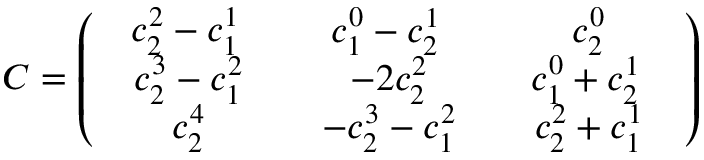Convert formula to latex. <formula><loc_0><loc_0><loc_500><loc_500>C = \left ( \begin{array} { c c c } { { \begin{array} { c } { { c _ { 2 } ^ { 2 } - c _ { 1 } ^ { 1 } } } \end{array} \, } } & { { \begin{array} { c } { { c _ { 1 } ^ { 0 } - c _ { 2 } ^ { 1 } } } \end{array} \, } } & { { \begin{array} { c } { { c _ { 2 } ^ { 0 } } } \end{array} } } \\ { { \begin{array} { c } { { c _ { 2 } ^ { 3 } - c _ { 1 } ^ { 2 } } } \end{array} } } & { { \begin{array} { c } { { - 2 c _ { 2 } ^ { 2 } } } \end{array} } } & { { \begin{array} { c } { { c _ { 1 } ^ { 0 } + c _ { 2 } ^ { 1 } } } \end{array} \, } } \\ { { \begin{array} { c } { { c _ { 2 } ^ { 4 } } } \end{array} } } & { { \begin{array} { c } { { - c _ { 2 } ^ { 3 } - c _ { 1 } ^ { 2 } } } \end{array} } } & { { \begin{array} { c } { { c _ { 2 } ^ { 2 } + c _ { 1 } ^ { 1 } } } \end{array} } } \end{array} \right )</formula> 